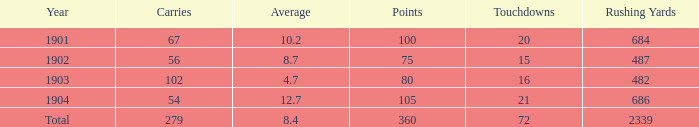What is the most number of touchdowns that have fewer than 105 points, averages over 4.7, and fewer than 487 rushing yards? None. 